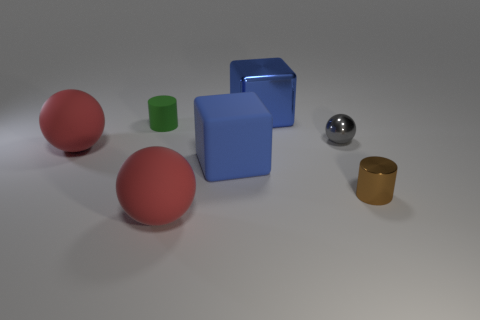Subtract all metallic spheres. How many spheres are left? 2 Subtract all gray cylinders. How many red spheres are left? 2 Add 1 gray shiny balls. How many objects exist? 8 Subtract all gray spheres. How many spheres are left? 2 Subtract all cylinders. How many objects are left? 5 Subtract all brown spheres. Subtract all blue cylinders. How many spheres are left? 3 Subtract all red rubber things. Subtract all gray spheres. How many objects are left? 4 Add 1 small shiny cylinders. How many small shiny cylinders are left? 2 Add 1 large metallic things. How many large metallic things exist? 2 Subtract 1 gray balls. How many objects are left? 6 